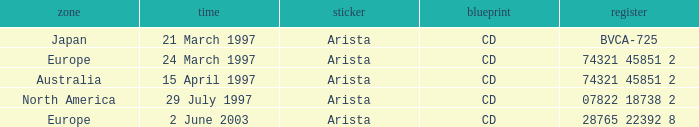On which date does the european region have a catalog of 74321 45851 2? 24 March 1997. Would you be able to parse every entry in this table? {'header': ['zone', 'time', 'sticker', 'blueprint', 'register'], 'rows': [['Japan', '21 March 1997', 'Arista', 'CD', 'BVCA-725'], ['Europe', '24 March 1997', 'Arista', 'CD', '74321 45851 2'], ['Australia', '15 April 1997', 'Arista', 'CD', '74321 45851 2'], ['North America', '29 July 1997', 'Arista', 'CD', '07822 18738 2'], ['Europe', '2 June 2003', 'Arista', 'CD', '28765 22392 8']]} 